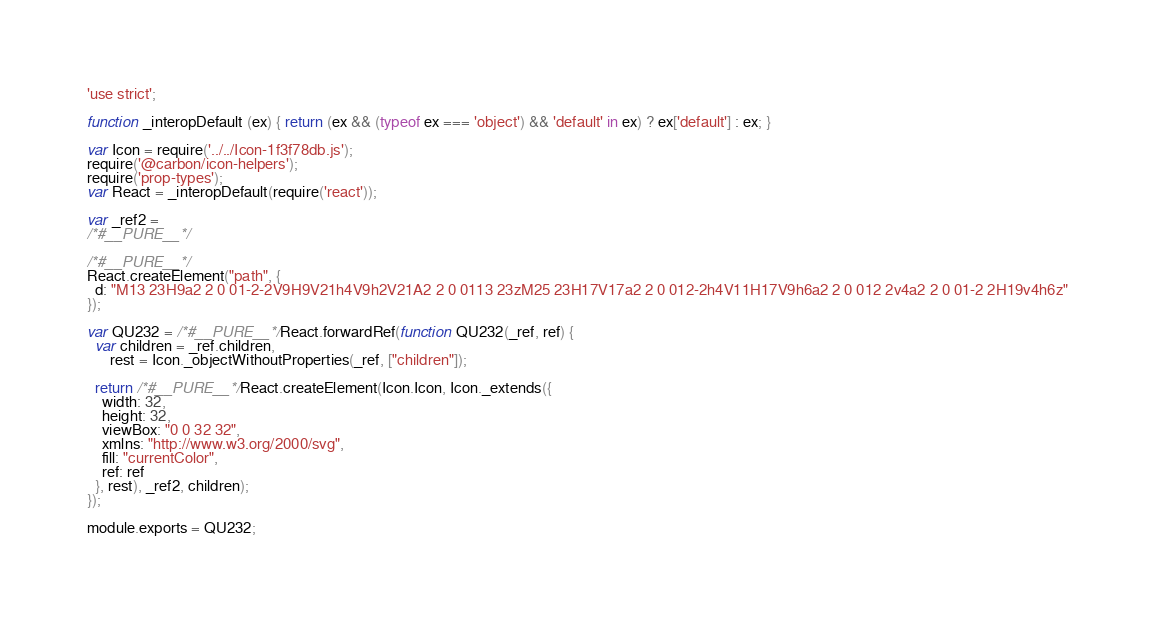<code> <loc_0><loc_0><loc_500><loc_500><_JavaScript_>'use strict';

function _interopDefault (ex) { return (ex && (typeof ex === 'object') && 'default' in ex) ? ex['default'] : ex; }

var Icon = require('../../Icon-1f3f78db.js');
require('@carbon/icon-helpers');
require('prop-types');
var React = _interopDefault(require('react'));

var _ref2 =
/*#__PURE__*/

/*#__PURE__*/
React.createElement("path", {
  d: "M13 23H9a2 2 0 01-2-2V9H9V21h4V9h2V21A2 2 0 0113 23zM25 23H17V17a2 2 0 012-2h4V11H17V9h6a2 2 0 012 2v4a2 2 0 01-2 2H19v4h6z"
});

var QU232 = /*#__PURE__*/React.forwardRef(function QU232(_ref, ref) {
  var children = _ref.children,
      rest = Icon._objectWithoutProperties(_ref, ["children"]);

  return /*#__PURE__*/React.createElement(Icon.Icon, Icon._extends({
    width: 32,
    height: 32,
    viewBox: "0 0 32 32",
    xmlns: "http://www.w3.org/2000/svg",
    fill: "currentColor",
    ref: ref
  }, rest), _ref2, children);
});

module.exports = QU232;
</code> 